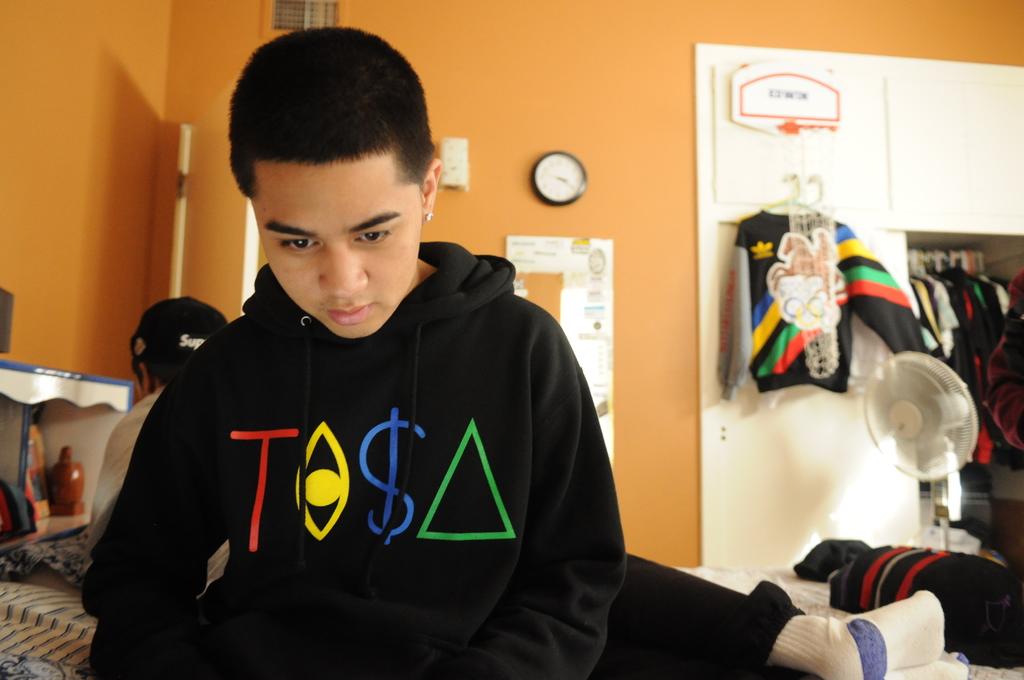What color is the letter t on the boy's hoodie?
Keep it short and to the point. Red. The boy looking?
Your answer should be compact. Answering does not require reading text in the image. 